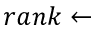<formula> <loc_0><loc_0><loc_500><loc_500>r a n k \leftarrow</formula> 